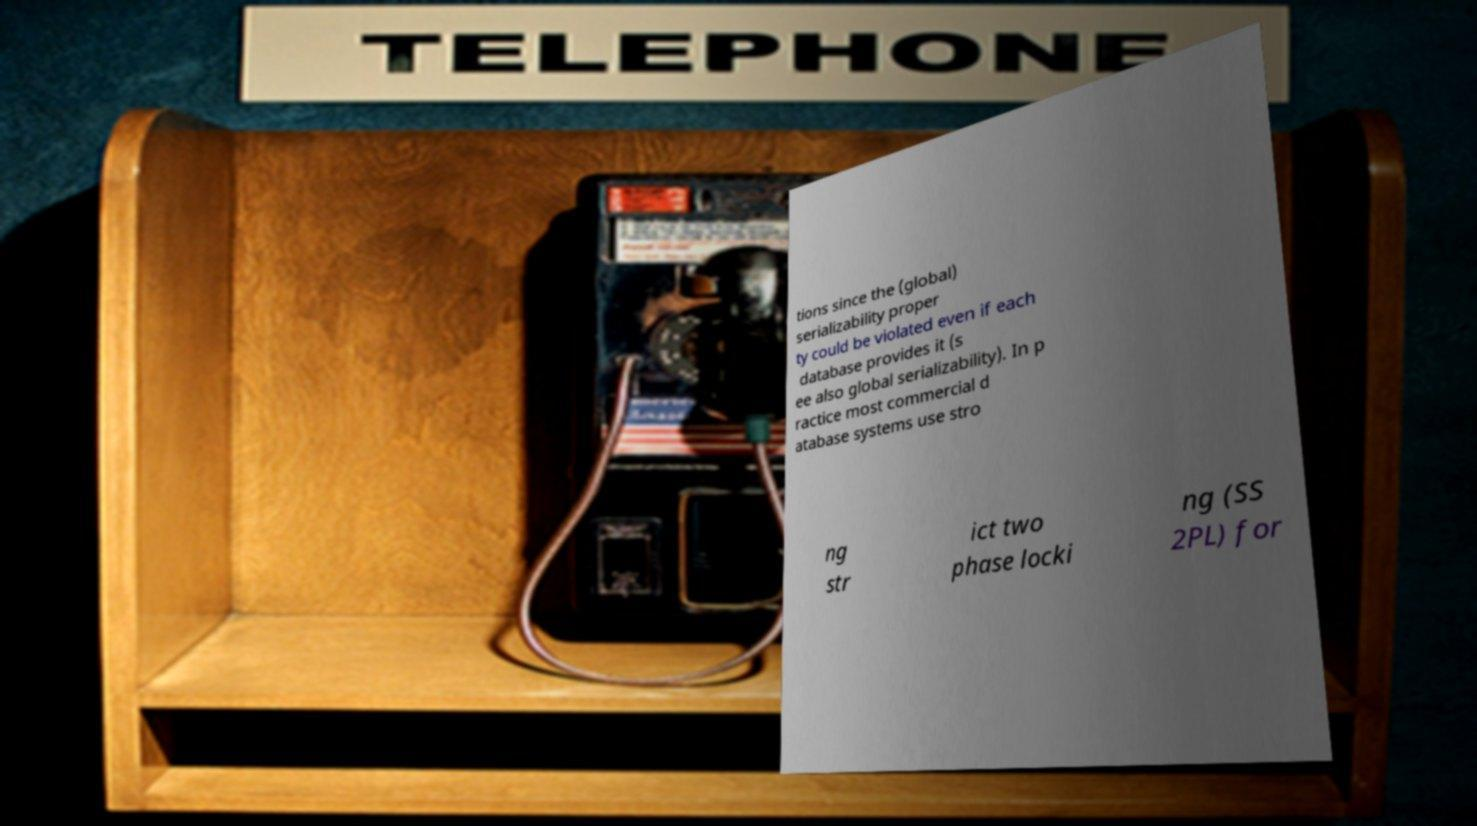For documentation purposes, I need the text within this image transcribed. Could you provide that? tions since the (global) serializability proper ty could be violated even if each database provides it (s ee also global serializability). In p ractice most commercial d atabase systems use stro ng str ict two phase locki ng (SS 2PL) for 